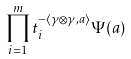Convert formula to latex. <formula><loc_0><loc_0><loc_500><loc_500>\prod _ { i = 1 } ^ { m } t _ { i } ^ { - \langle \gamma \otimes \gamma , a \rangle } \Psi ( a )</formula> 